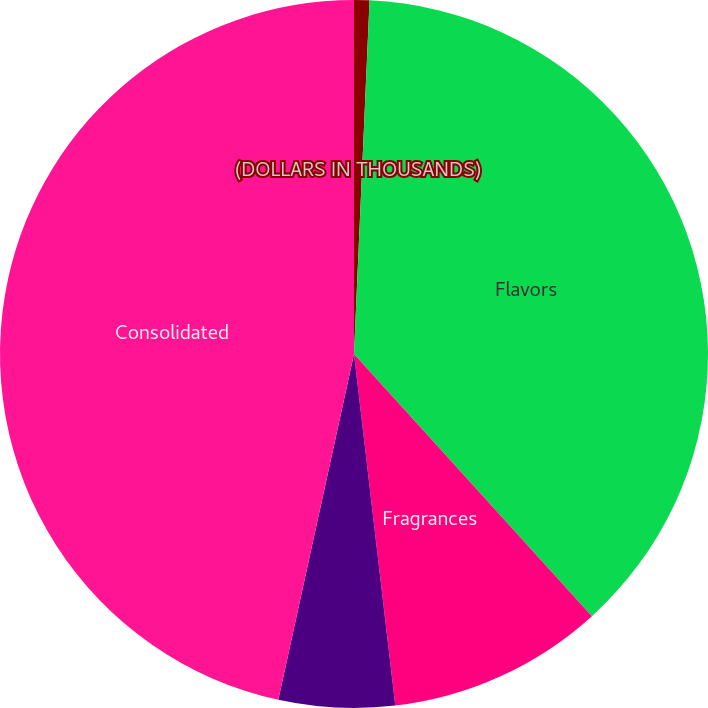<chart> <loc_0><loc_0><loc_500><loc_500><pie_chart><fcel>(DOLLARS IN THOUSANDS)<fcel>Flavors<fcel>Fragrances<fcel>Unallocated assets<fcel>Consolidated<nl><fcel>0.7%<fcel>37.57%<fcel>9.87%<fcel>5.29%<fcel>46.57%<nl></chart> 